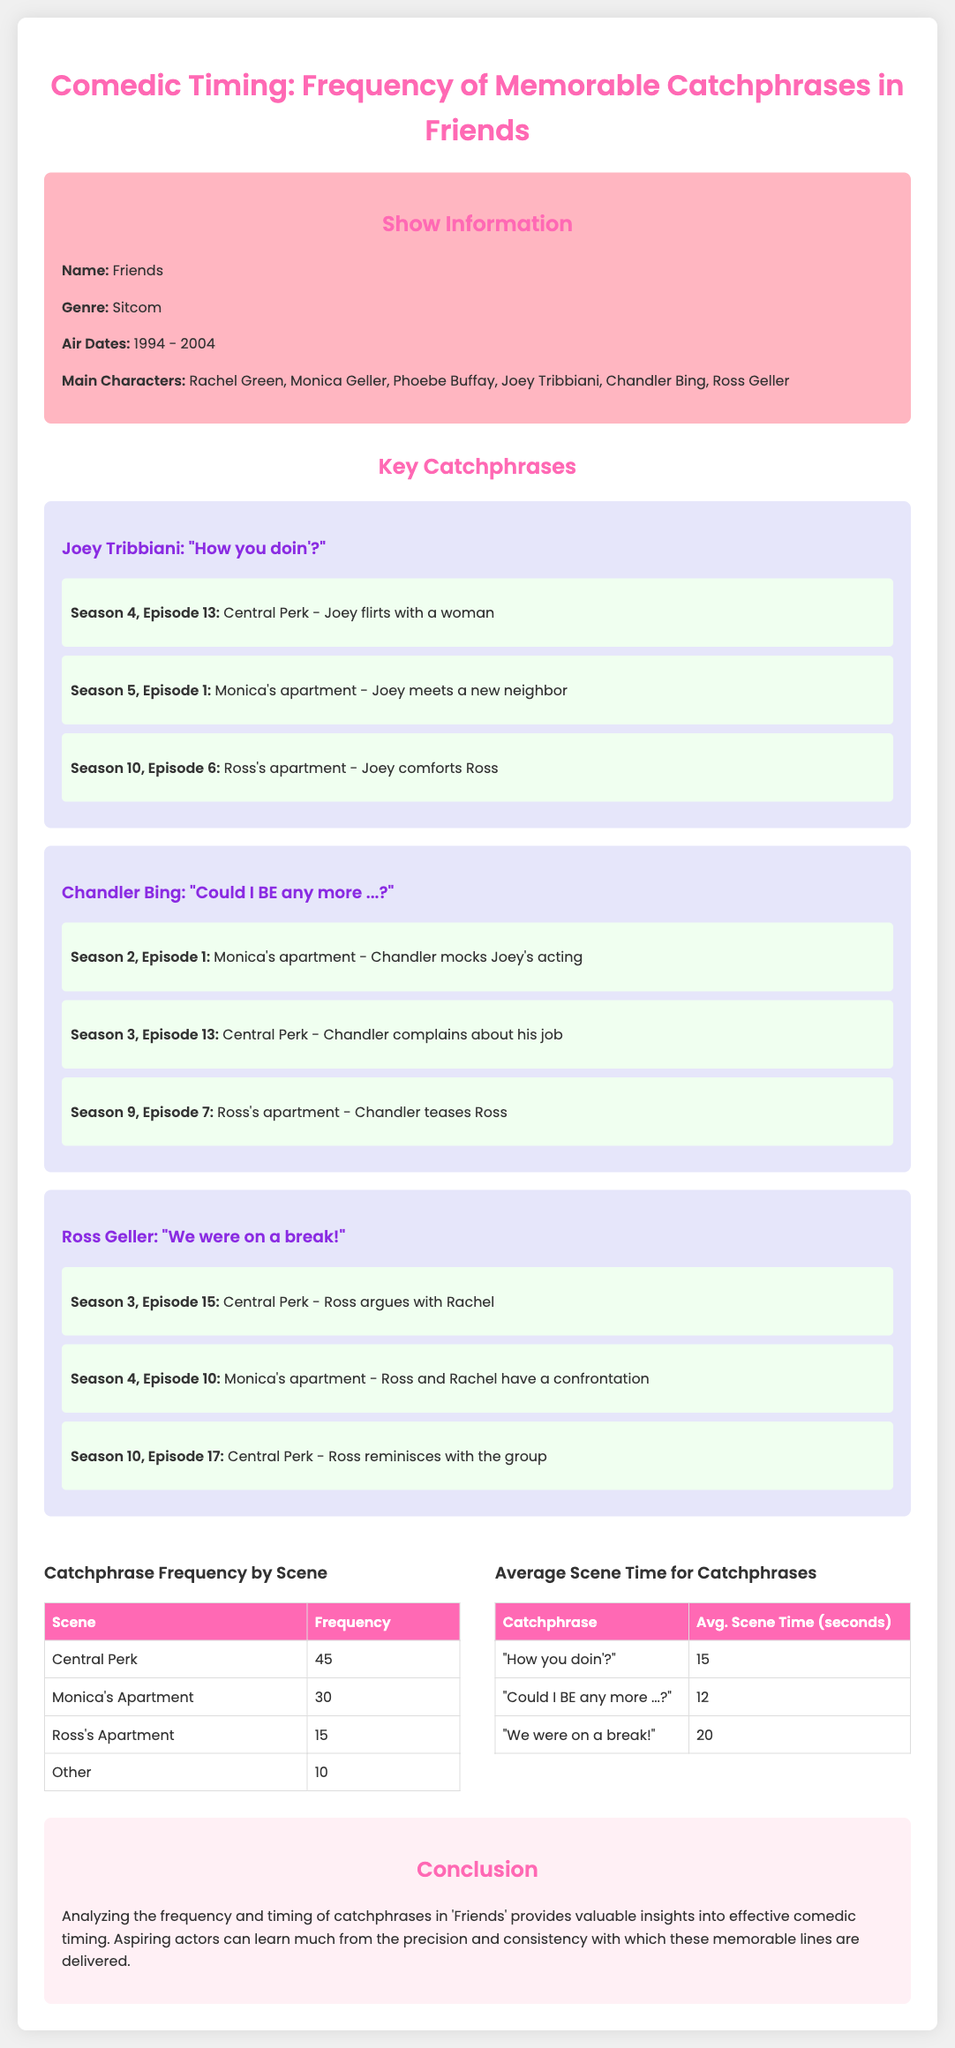What is the name of the show? The show being analyzed is identified in the document as "Friends".
Answer: Friends What was the air date range for the show? The air dates are specified in the document as starting in 1994 and ending in 2004.
Answer: 1994 - 2004 How many catchphrases are highlighted in the infographic? Three key catchphrases are presented in the document.
Answer: Three Which catchphrase has the highest average scene time? "We were on a break!" has the highest average scene time listed in the document.
Answer: "We were on a break!" What is the frequency of catchphrases used in Central Perk? The document indicates that the frequency of catchphrases in Central Perk is 45.
Answer: 45 Which character says, "How you doin'?" The character associated with this catchphrase, according to the document, is Joey Tribbiani.
Answer: Joey Tribbiani What scene has the lowest frequency for catchphrases? The scene categorized as "Other" has the lowest frequency of catchphrases according to the document.
Answer: Other What is the average scene time for "Could I BE any more ...?" The document states that the average scene time for this catchphrase is 12 seconds.
Answer: 12 What genre is the show "Friends"? The genre of the show is stated in the document as "Sitcom".
Answer: Sitcom 